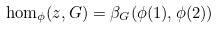<formula> <loc_0><loc_0><loc_500><loc_500>\hom _ { \phi } ( z , G ) = \beta _ { G } ( \phi ( 1 ) , \phi ( 2 ) )</formula> 